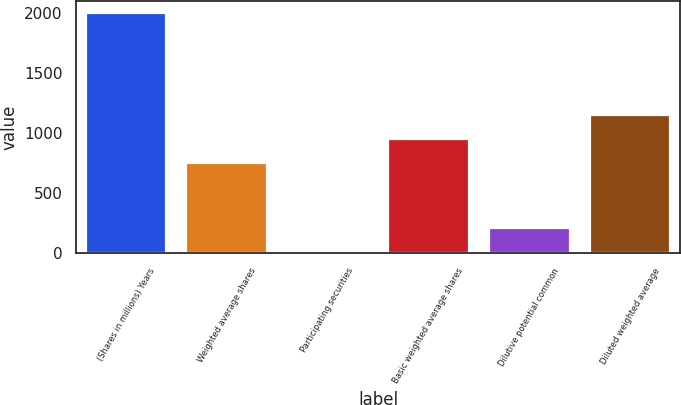Convert chart. <chart><loc_0><loc_0><loc_500><loc_500><bar_chart><fcel>(Shares in millions) Years<fcel>Weighted average shares<fcel>Participating securities<fcel>Basic weighted average shares<fcel>Dilutive potential common<fcel>Diluted weighted average<nl><fcel>2007<fcel>750.5<fcel>8.8<fcel>950.32<fcel>208.62<fcel>1150.14<nl></chart> 